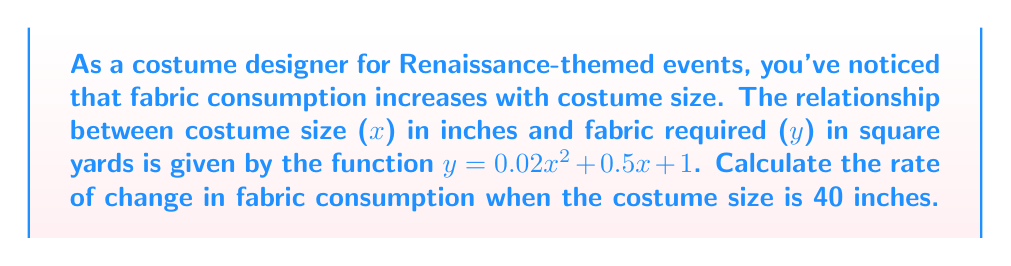Show me your answer to this math problem. To find the rate of change in fabric consumption, we need to calculate the derivative of the given function and evaluate it at x = 40.

1. The given function is: $y = 0.02x^2 + 0.5x + 1$

2. To find the derivative, we use the power rule and constant rule:
   $\frac{dy}{dx} = 0.02 \cdot 2x^{2-1} + 0.5 + 0$
   $\frac{dy}{dx} = 0.04x + 0.5$

3. This derivative represents the rate of change in fabric consumption for any given costume size.

4. To find the rate of change when the costume size is 40 inches, we substitute x = 40 into the derivative:
   $\frac{dy}{dx}|_{x=40} = 0.04(40) + 0.5$
   $\frac{dy}{dx}|_{x=40} = 1.6 + 0.5 = 2.1$

5. The result, 2.1, represents the rate of change in square yards of fabric per inch of costume size when the costume size is 40 inches.
Answer: 2.1 square yards per inch 